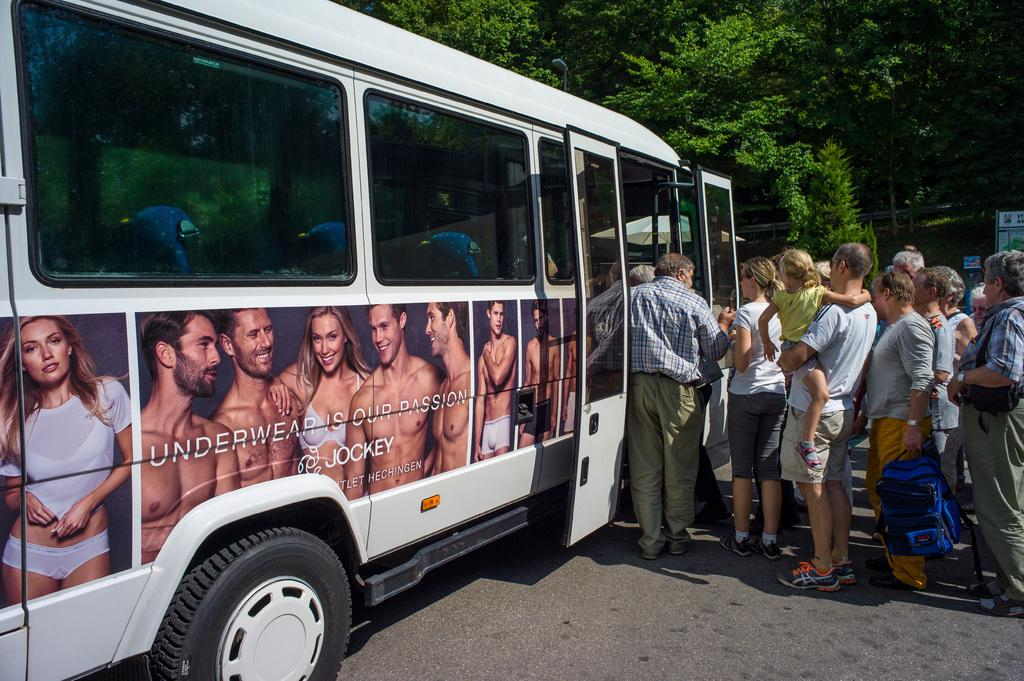Provide a one-sentence caption for the provided image. people getting on a white bus that has a jockey underwear ad on it. 